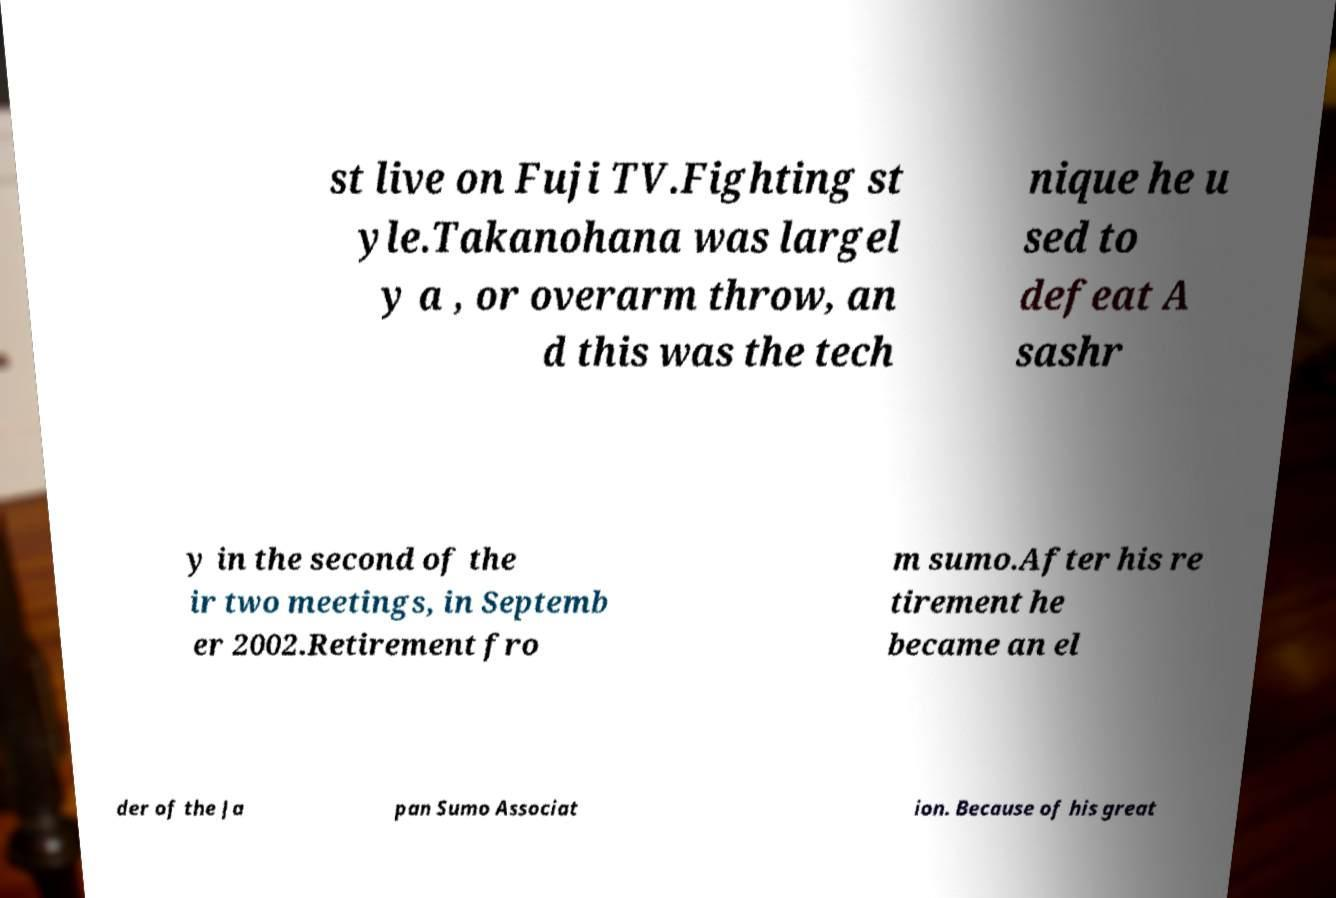There's text embedded in this image that I need extracted. Can you transcribe it verbatim? st live on Fuji TV.Fighting st yle.Takanohana was largel y a , or overarm throw, an d this was the tech nique he u sed to defeat A sashr y in the second of the ir two meetings, in Septemb er 2002.Retirement fro m sumo.After his re tirement he became an el der of the Ja pan Sumo Associat ion. Because of his great 